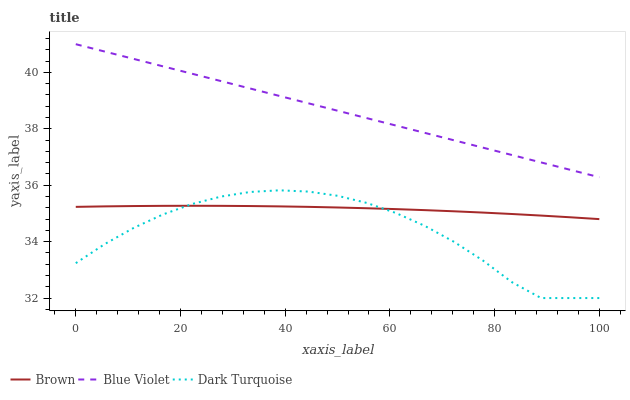Does Blue Violet have the minimum area under the curve?
Answer yes or no. No. Does Dark Turquoise have the maximum area under the curve?
Answer yes or no. No. Is Dark Turquoise the smoothest?
Answer yes or no. No. Is Blue Violet the roughest?
Answer yes or no. No. Does Blue Violet have the lowest value?
Answer yes or no. No. Does Dark Turquoise have the highest value?
Answer yes or no. No. Is Brown less than Blue Violet?
Answer yes or no. Yes. Is Blue Violet greater than Brown?
Answer yes or no. Yes. Does Brown intersect Blue Violet?
Answer yes or no. No. 